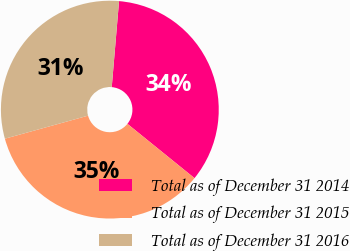Convert chart. <chart><loc_0><loc_0><loc_500><loc_500><pie_chart><fcel>Total as of December 31 2014<fcel>Total as of December 31 2015<fcel>Total as of December 31 2016<nl><fcel>34.48%<fcel>34.87%<fcel>30.65%<nl></chart> 